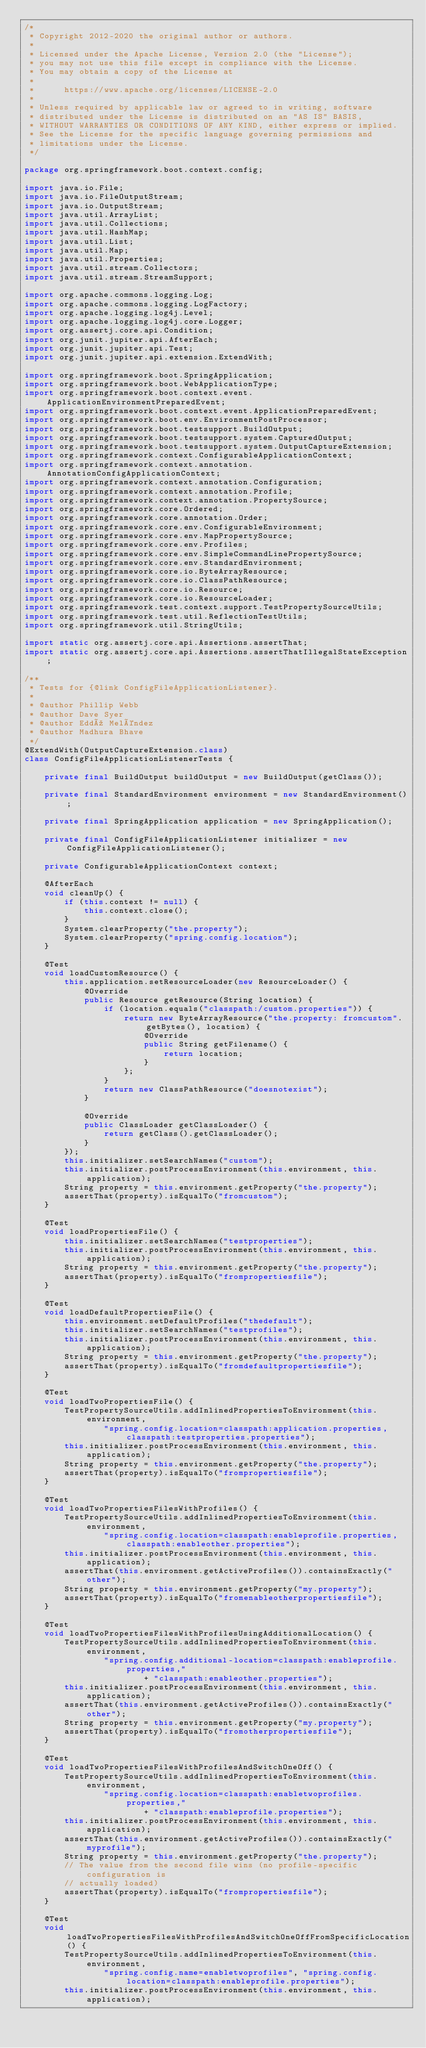<code> <loc_0><loc_0><loc_500><loc_500><_Java_>/*
 * Copyright 2012-2020 the original author or authors.
 *
 * Licensed under the Apache License, Version 2.0 (the "License");
 * you may not use this file except in compliance with the License.
 * You may obtain a copy of the License at
 *
 *      https://www.apache.org/licenses/LICENSE-2.0
 *
 * Unless required by applicable law or agreed to in writing, software
 * distributed under the License is distributed on an "AS IS" BASIS,
 * WITHOUT WARRANTIES OR CONDITIONS OF ANY KIND, either express or implied.
 * See the License for the specific language governing permissions and
 * limitations under the License.
 */

package org.springframework.boot.context.config;

import java.io.File;
import java.io.FileOutputStream;
import java.io.OutputStream;
import java.util.ArrayList;
import java.util.Collections;
import java.util.HashMap;
import java.util.List;
import java.util.Map;
import java.util.Properties;
import java.util.stream.Collectors;
import java.util.stream.StreamSupport;

import org.apache.commons.logging.Log;
import org.apache.commons.logging.LogFactory;
import org.apache.logging.log4j.Level;
import org.apache.logging.log4j.core.Logger;
import org.assertj.core.api.Condition;
import org.junit.jupiter.api.AfterEach;
import org.junit.jupiter.api.Test;
import org.junit.jupiter.api.extension.ExtendWith;

import org.springframework.boot.SpringApplication;
import org.springframework.boot.WebApplicationType;
import org.springframework.boot.context.event.ApplicationEnvironmentPreparedEvent;
import org.springframework.boot.context.event.ApplicationPreparedEvent;
import org.springframework.boot.env.EnvironmentPostProcessor;
import org.springframework.boot.testsupport.BuildOutput;
import org.springframework.boot.testsupport.system.CapturedOutput;
import org.springframework.boot.testsupport.system.OutputCaptureExtension;
import org.springframework.context.ConfigurableApplicationContext;
import org.springframework.context.annotation.AnnotationConfigApplicationContext;
import org.springframework.context.annotation.Configuration;
import org.springframework.context.annotation.Profile;
import org.springframework.context.annotation.PropertySource;
import org.springframework.core.Ordered;
import org.springframework.core.annotation.Order;
import org.springframework.core.env.ConfigurableEnvironment;
import org.springframework.core.env.MapPropertySource;
import org.springframework.core.env.Profiles;
import org.springframework.core.env.SimpleCommandLinePropertySource;
import org.springframework.core.env.StandardEnvironment;
import org.springframework.core.io.ByteArrayResource;
import org.springframework.core.io.ClassPathResource;
import org.springframework.core.io.Resource;
import org.springframework.core.io.ResourceLoader;
import org.springframework.test.context.support.TestPropertySourceUtils;
import org.springframework.test.util.ReflectionTestUtils;
import org.springframework.util.StringUtils;

import static org.assertj.core.api.Assertions.assertThat;
import static org.assertj.core.api.Assertions.assertThatIllegalStateException;

/**
 * Tests for {@link ConfigFileApplicationListener}.
 *
 * @author Phillip Webb
 * @author Dave Syer
 * @author Eddú Meléndez
 * @author Madhura Bhave
 */
@ExtendWith(OutputCaptureExtension.class)
class ConfigFileApplicationListenerTests {

	private final BuildOutput buildOutput = new BuildOutput(getClass());

	private final StandardEnvironment environment = new StandardEnvironment();

	private final SpringApplication application = new SpringApplication();

	private final ConfigFileApplicationListener initializer = new ConfigFileApplicationListener();

	private ConfigurableApplicationContext context;

	@AfterEach
	void cleanUp() {
		if (this.context != null) {
			this.context.close();
		}
		System.clearProperty("the.property");
		System.clearProperty("spring.config.location");
	}

	@Test
	void loadCustomResource() {
		this.application.setResourceLoader(new ResourceLoader() {
			@Override
			public Resource getResource(String location) {
				if (location.equals("classpath:/custom.properties")) {
					return new ByteArrayResource("the.property: fromcustom".getBytes(), location) {
						@Override
						public String getFilename() {
							return location;
						}
					};
				}
				return new ClassPathResource("doesnotexist");
			}

			@Override
			public ClassLoader getClassLoader() {
				return getClass().getClassLoader();
			}
		});
		this.initializer.setSearchNames("custom");
		this.initializer.postProcessEnvironment(this.environment, this.application);
		String property = this.environment.getProperty("the.property");
		assertThat(property).isEqualTo("fromcustom");
	}

	@Test
	void loadPropertiesFile() {
		this.initializer.setSearchNames("testproperties");
		this.initializer.postProcessEnvironment(this.environment, this.application);
		String property = this.environment.getProperty("the.property");
		assertThat(property).isEqualTo("frompropertiesfile");
	}

	@Test
	void loadDefaultPropertiesFile() {
		this.environment.setDefaultProfiles("thedefault");
		this.initializer.setSearchNames("testprofiles");
		this.initializer.postProcessEnvironment(this.environment, this.application);
		String property = this.environment.getProperty("the.property");
		assertThat(property).isEqualTo("fromdefaultpropertiesfile");
	}

	@Test
	void loadTwoPropertiesFile() {
		TestPropertySourceUtils.addInlinedPropertiesToEnvironment(this.environment,
				"spring.config.location=classpath:application.properties,classpath:testproperties.properties");
		this.initializer.postProcessEnvironment(this.environment, this.application);
		String property = this.environment.getProperty("the.property");
		assertThat(property).isEqualTo("frompropertiesfile");
	}

	@Test
	void loadTwoPropertiesFilesWithProfiles() {
		TestPropertySourceUtils.addInlinedPropertiesToEnvironment(this.environment,
				"spring.config.location=classpath:enableprofile.properties,classpath:enableother.properties");
		this.initializer.postProcessEnvironment(this.environment, this.application);
		assertThat(this.environment.getActiveProfiles()).containsExactly("other");
		String property = this.environment.getProperty("my.property");
		assertThat(property).isEqualTo("fromenableotherpropertiesfile");
	}

	@Test
	void loadTwoPropertiesFilesWithProfilesUsingAdditionalLocation() {
		TestPropertySourceUtils.addInlinedPropertiesToEnvironment(this.environment,
				"spring.config.additional-location=classpath:enableprofile.properties,"
						+ "classpath:enableother.properties");
		this.initializer.postProcessEnvironment(this.environment, this.application);
		assertThat(this.environment.getActiveProfiles()).containsExactly("other");
		String property = this.environment.getProperty("my.property");
		assertThat(property).isEqualTo("fromotherpropertiesfile");
	}

	@Test
	void loadTwoPropertiesFilesWithProfilesAndSwitchOneOff() {
		TestPropertySourceUtils.addInlinedPropertiesToEnvironment(this.environment,
				"spring.config.location=classpath:enabletwoprofiles.properties,"
						+ "classpath:enableprofile.properties");
		this.initializer.postProcessEnvironment(this.environment, this.application);
		assertThat(this.environment.getActiveProfiles()).containsExactly("myprofile");
		String property = this.environment.getProperty("the.property");
		// The value from the second file wins (no profile-specific configuration is
		// actually loaded)
		assertThat(property).isEqualTo("frompropertiesfile");
	}

	@Test
	void loadTwoPropertiesFilesWithProfilesAndSwitchOneOffFromSpecificLocation() {
		TestPropertySourceUtils.addInlinedPropertiesToEnvironment(this.environment,
				"spring.config.name=enabletwoprofiles", "spring.config.location=classpath:enableprofile.properties");
		this.initializer.postProcessEnvironment(this.environment, this.application);</code> 